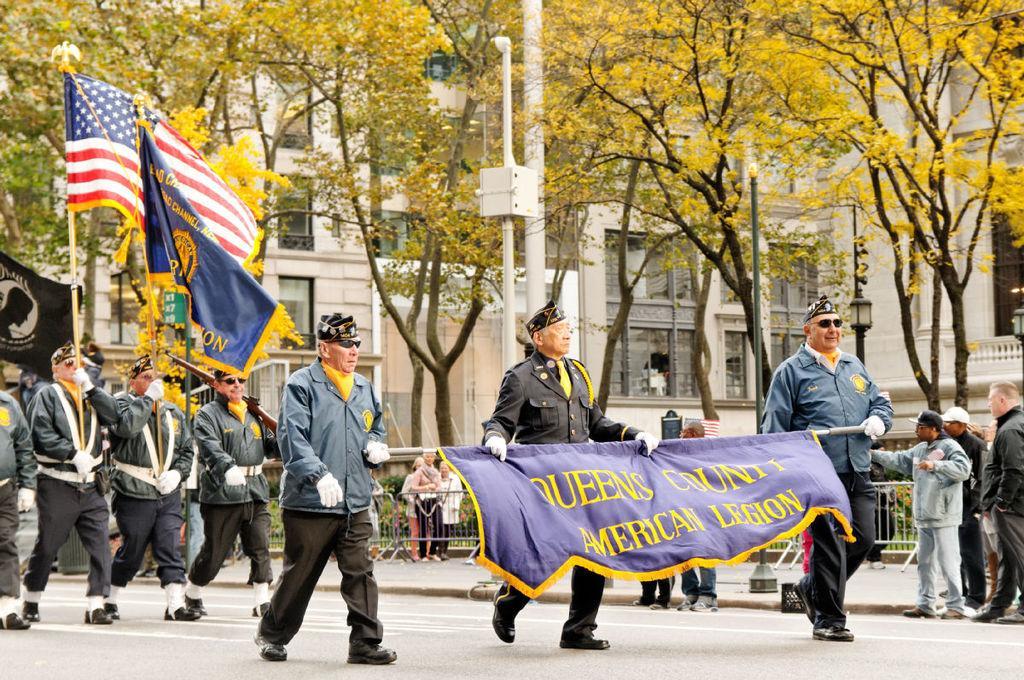How would you summarize this image in a sentence or two? In this image few persons are walking on the road. There persons are holding the road which is having a flag to it. A person is holding gun. Beside there are two persons holding sticks having flags. There are few persons standing on the road. There are few poles on the pavement. There are few persons behind the fence. Background there are few trees and buildings. 